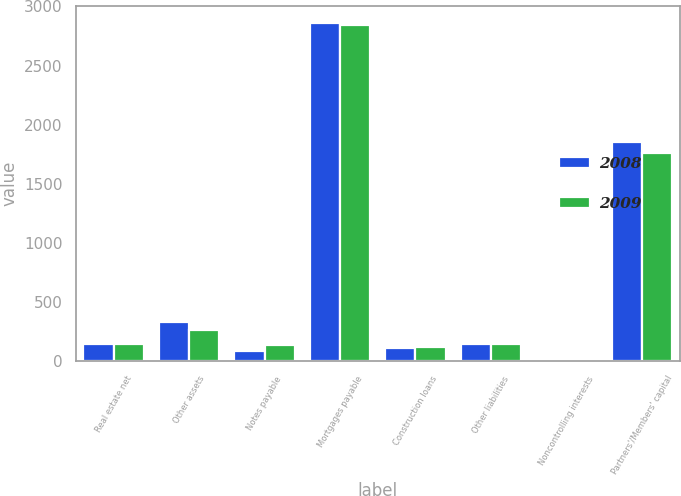<chart> <loc_0><loc_0><loc_500><loc_500><stacked_bar_chart><ecel><fcel>Real estate net<fcel>Other assets<fcel>Notes payable<fcel>Mortgages payable<fcel>Construction loans<fcel>Other liabilities<fcel>Noncontrolling interests<fcel>Partners'/Members' capital<nl><fcel>2008<fcel>147.6<fcel>333.9<fcel>88.3<fcel>2862.6<fcel>109<fcel>146.2<fcel>1.6<fcel>1851.4<nl><fcel>2009<fcel>147.6<fcel>267.1<fcel>137.1<fcel>2842.2<fcel>119.6<fcel>149<fcel>1<fcel>1757.7<nl></chart> 